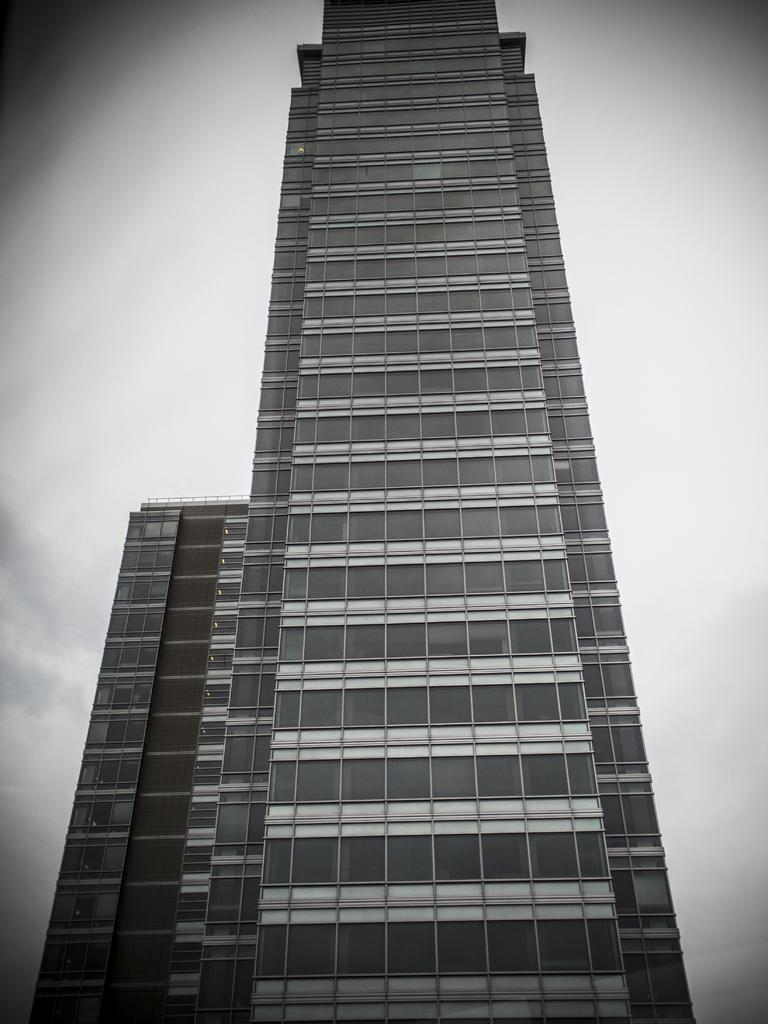What is the color scheme of the image? The image is black and white. What structure can be seen in the image? There is a building in the image. What can be seen in the background of the image? The sky is visible in the background of the image. What is the condition of the sky in the image? Clouds are present in the sky. Can you tell me where the crate is located in the image? There is no crate present in the image. What type of cemetery can be seen in the image? There is no cemetery present in the image. 